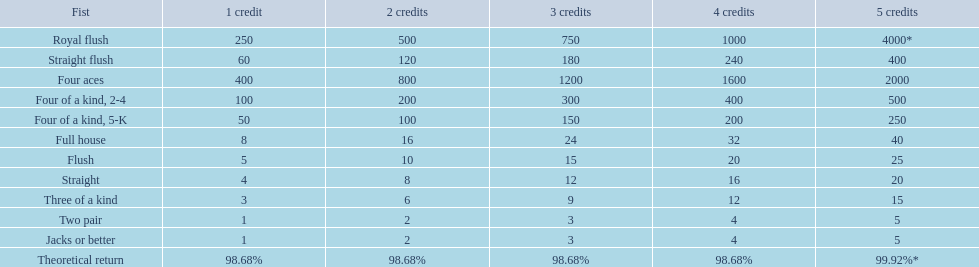Which hand is the third best hand in the card game super aces? Four aces. Which hand is the second best hand? Straight flush. Which hand had is the best hand? Royal flush. 